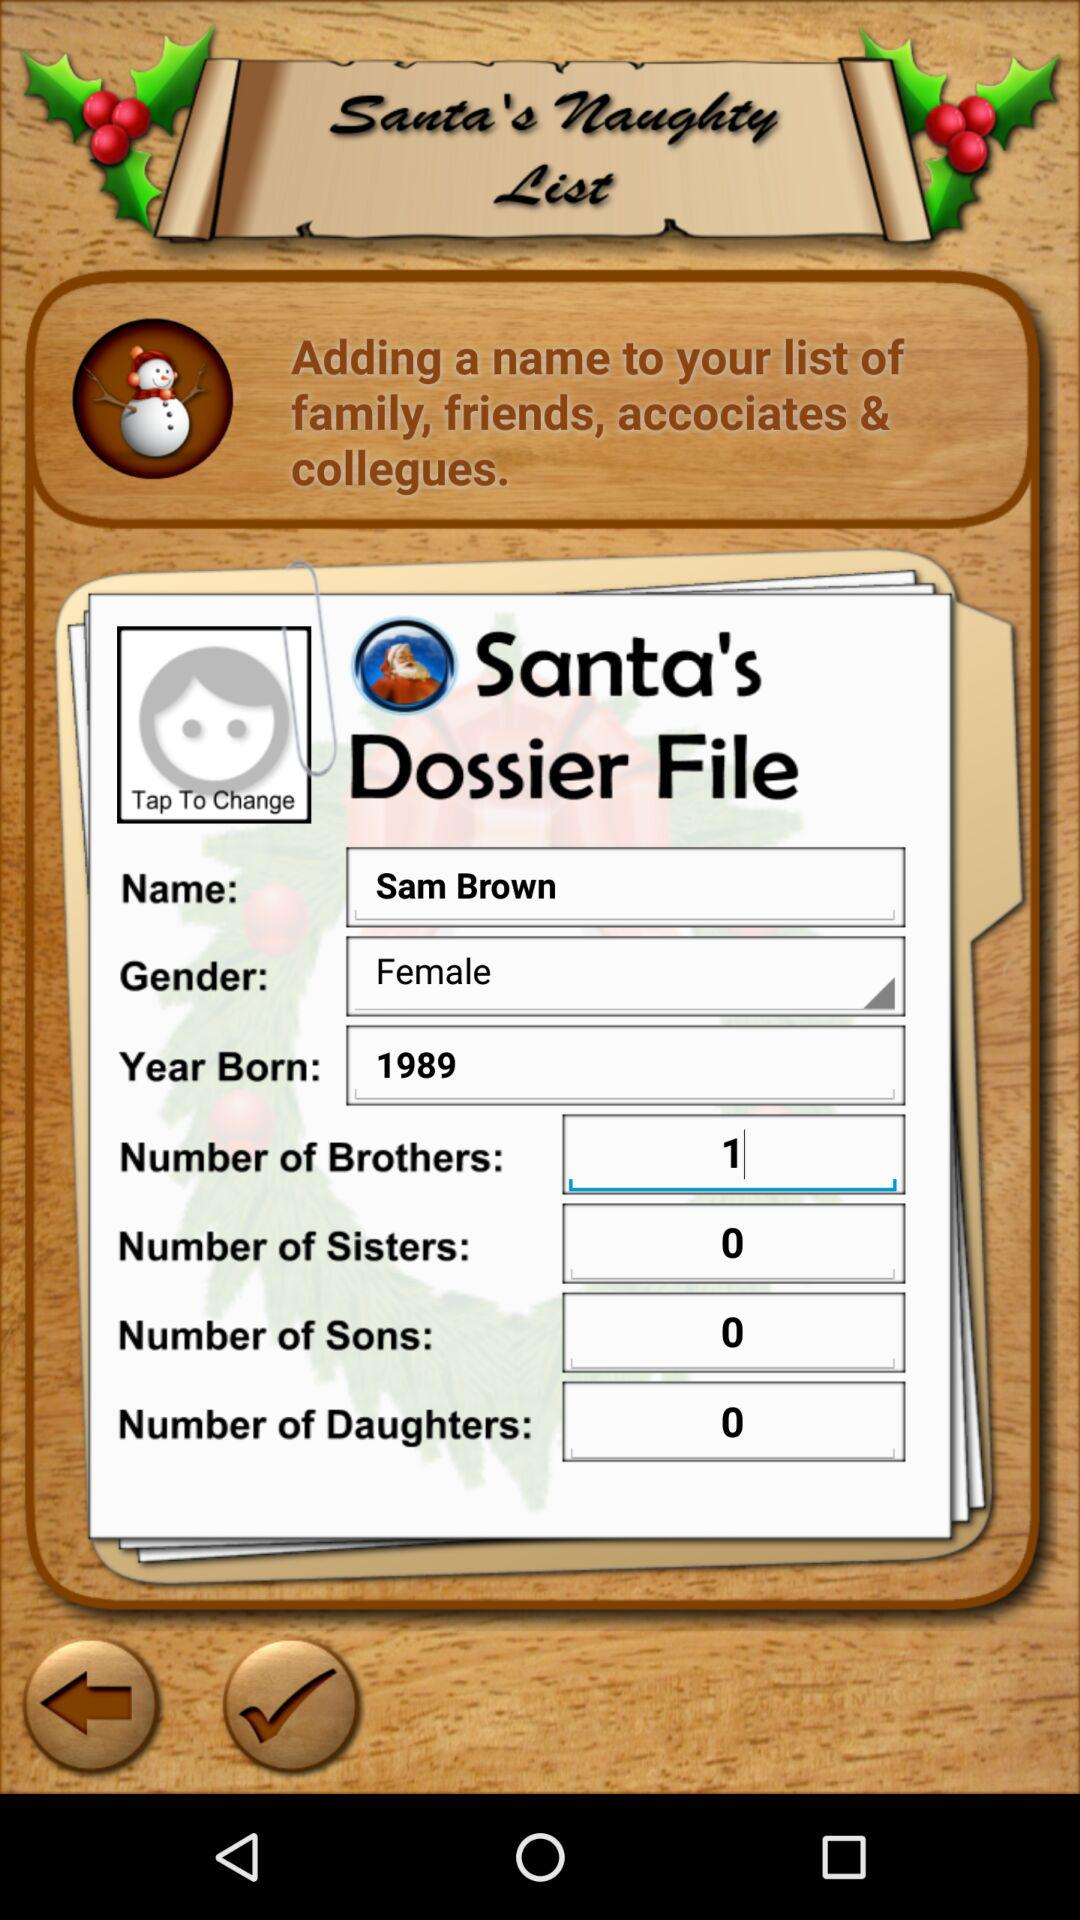What is the year of birth of the user? The year of birth of the user is 1989. 